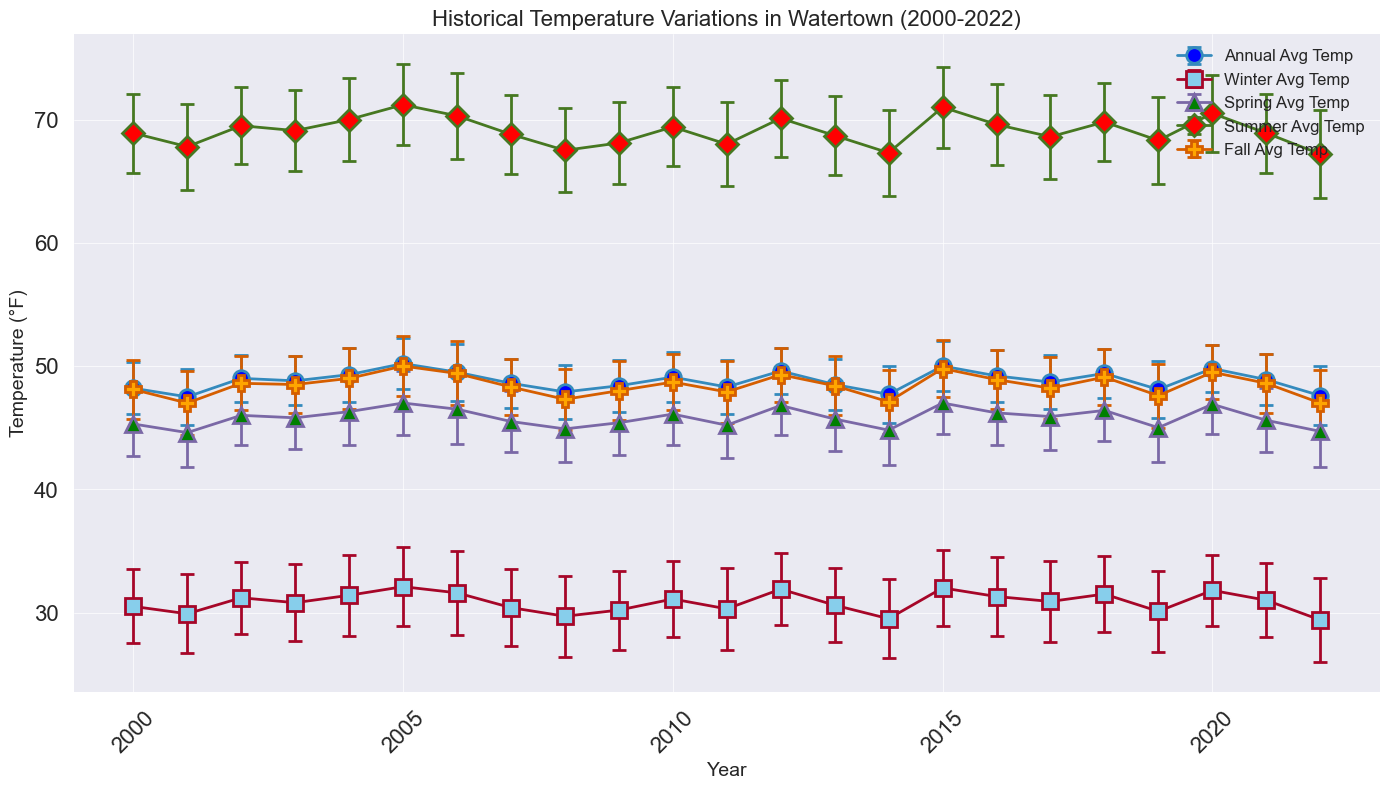What's the highest recorded annual average temperature from 2000 to 2022? Look at the trend of the annual average temperatures over the years. The highest value is seen around 2005 and 2015. Verify the exact highest value by locating the peak value from the annual averages.
Answer: 50.2°F How do the winter average temperatures compare to the summer average temperatures in 2020? Referring to the temperature lines, compare the specific points for winter and summer in 2020. The winter average temperature is around 31.8°F, and the summer average temperature is about 70.5°F. Clearly, the summer temperature is higher.
Answer: Summer gets much hotter compared to winter Which year showed the most significant increase in annual average temperature compared to the previous year? This involves observing the difference in the annual average temperature from one year to the next. Look at the annual average lines for abrupt rises. The most significant jump happens between 2004 and 2005. Compute the exact difference as 50.2°F in 2005 minus 49.3°F in 2004.
Answer: Between 2004 and 2005 What's the average winter temperature over the entire data period? Find the average of the winter average temperatures from 2000 to 2022. Sum up all winter average temperatures and divide by the number of years.
Answer: ((30.5 + 29.9 + 31.2 + 30.8 + 31.4 + 32.1 + 31.6 + 30.4 + 29.7 + 30.2 + 31.1 + 30.3 + 31.9 + 30.6 + 29.5 + 32.0 + 31.3 + 30.9 + 31.5 + 30.1 + 31.8 + 31.0 + 29.4) / 23) ≈ 30.8°F In which year was the fall average temperature closest to the annual average temperature? Observe the fall average temperature relative to the annual average temperature for each year. The data shows that in 2000, 2003, and 2010, fall averages are very close to annual averages. By close inspection, 2000 stands out clearly. Check numerically: Fall 48.1°F, Annual 48.2°F in 2000.
Answer: 2000 Which season shows the highest variability in temperatures based on the standard deviations? Look at the error bars for each season. The width of these bars shows variability. By comparing them, summer consistently shows wider error bars across years, indicating higher variability. Specifically, the summer standard deviations range from approximately 3.1 to 3.6, which are generally higher than other seasons' deviations.
Answer: Summer Was there any year where the winter temperature was higher than the fall temperature? Compare winter and fall average temperatures year by year. Specifically look for years when winter points are above fall points. Review verification shows that 2004 (Winter 31.4°F, Fall 29.7°F) is the year.
Answer: 2004 In which year did the fall temperature drop to the lowest, and what was the value? Track the fall temperature trendline to locate the lowest point. It appears around 2022. Double-checking, 2022 value for fall is 46.5°F.
Answer: 2022, 29.4°F 